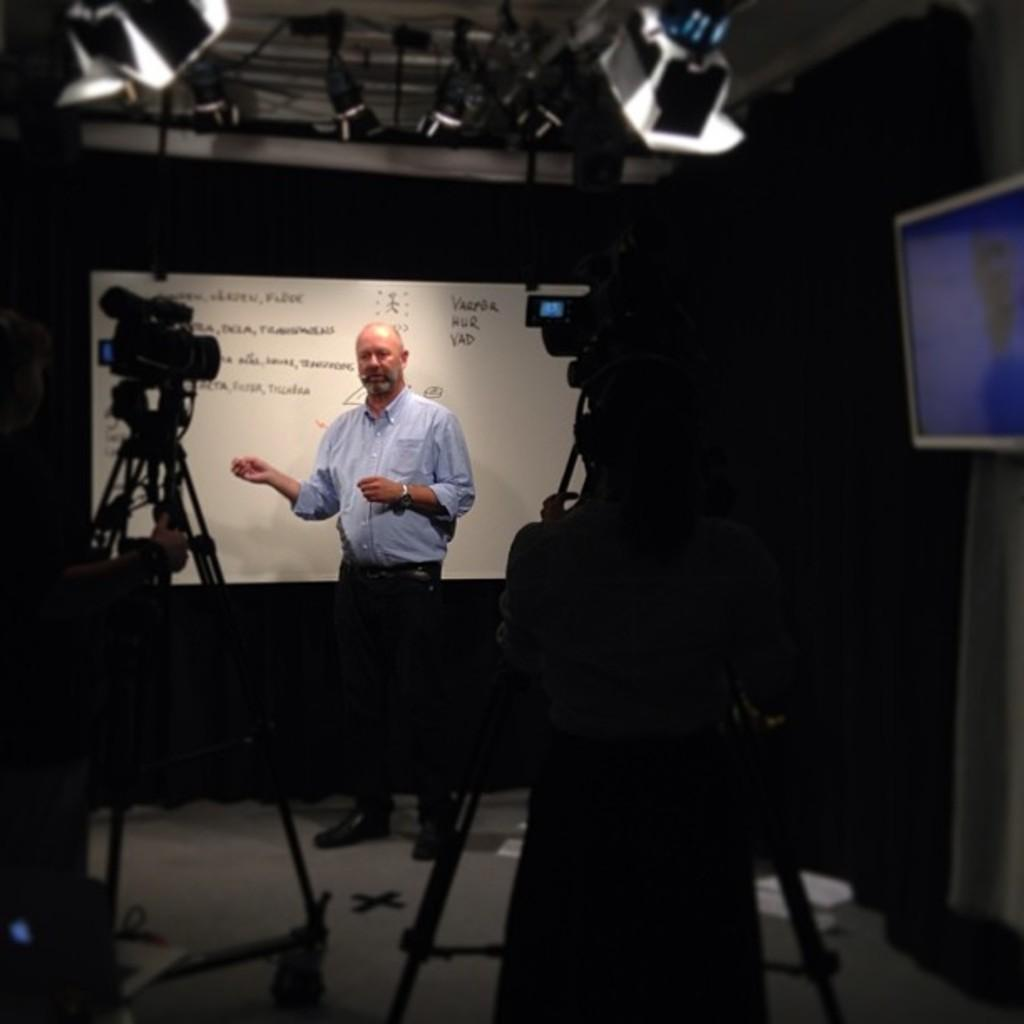What is the main subject in the image? There is a person standing in the image. What is the person standing near? There is a whiteboard with writing in the image. What else can be seen in the image? Cameras are present in the image. What type of fruit is being crushed by the wren in the image? There is no wren or fruit present in the image. 